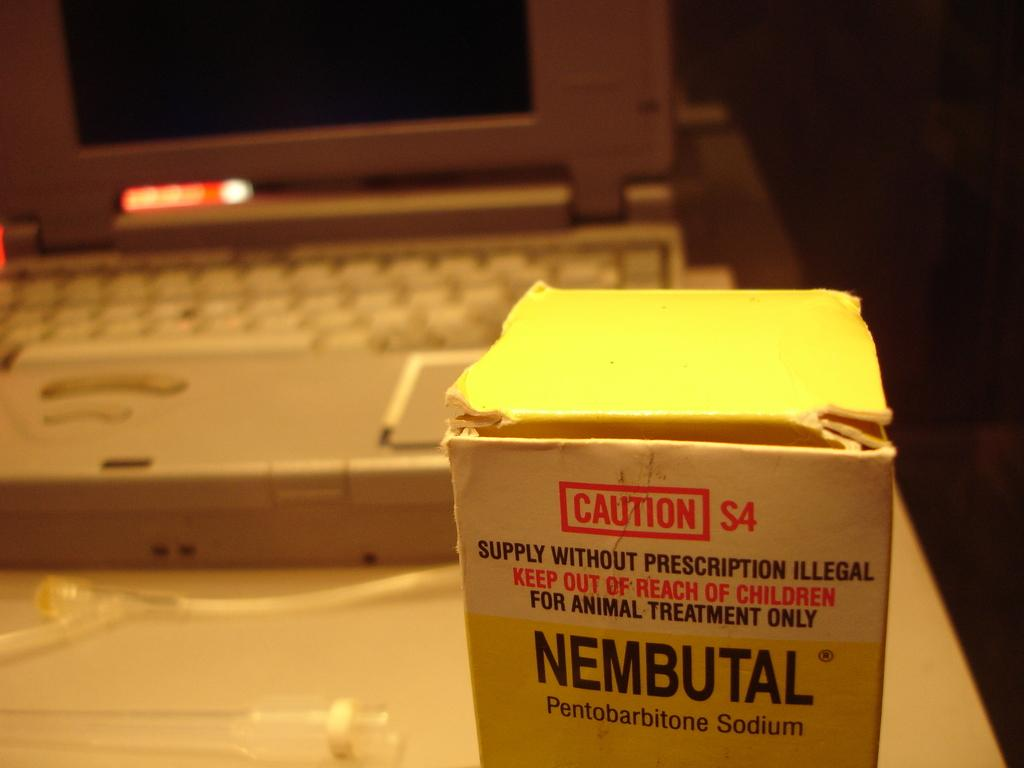<image>
Present a compact description of the photo's key features. The box shown has a caution label on it to warn others of the medication inside. 